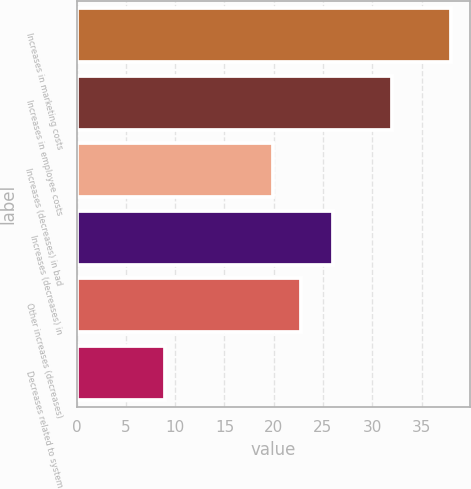Convert chart to OTSL. <chart><loc_0><loc_0><loc_500><loc_500><bar_chart><fcel>Increases in marketing costs<fcel>Increases in employee costs<fcel>Increases (decreases) in bad<fcel>Increases (decreases) in<fcel>Other increases (decreases)<fcel>Decreases related to system<nl><fcel>38<fcel>32<fcel>19.9<fcel>26<fcel>22.8<fcel>9<nl></chart> 